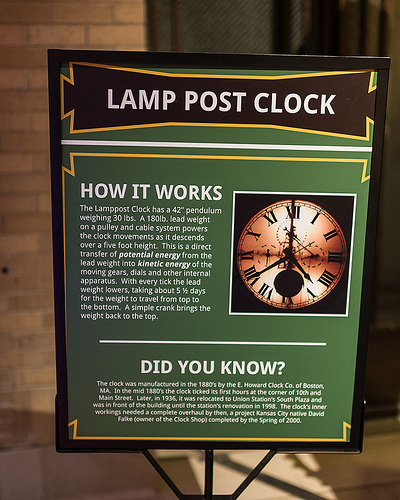<image>
Is the clock on the sign? Yes. Looking at the image, I can see the clock is positioned on top of the sign, with the sign providing support. 